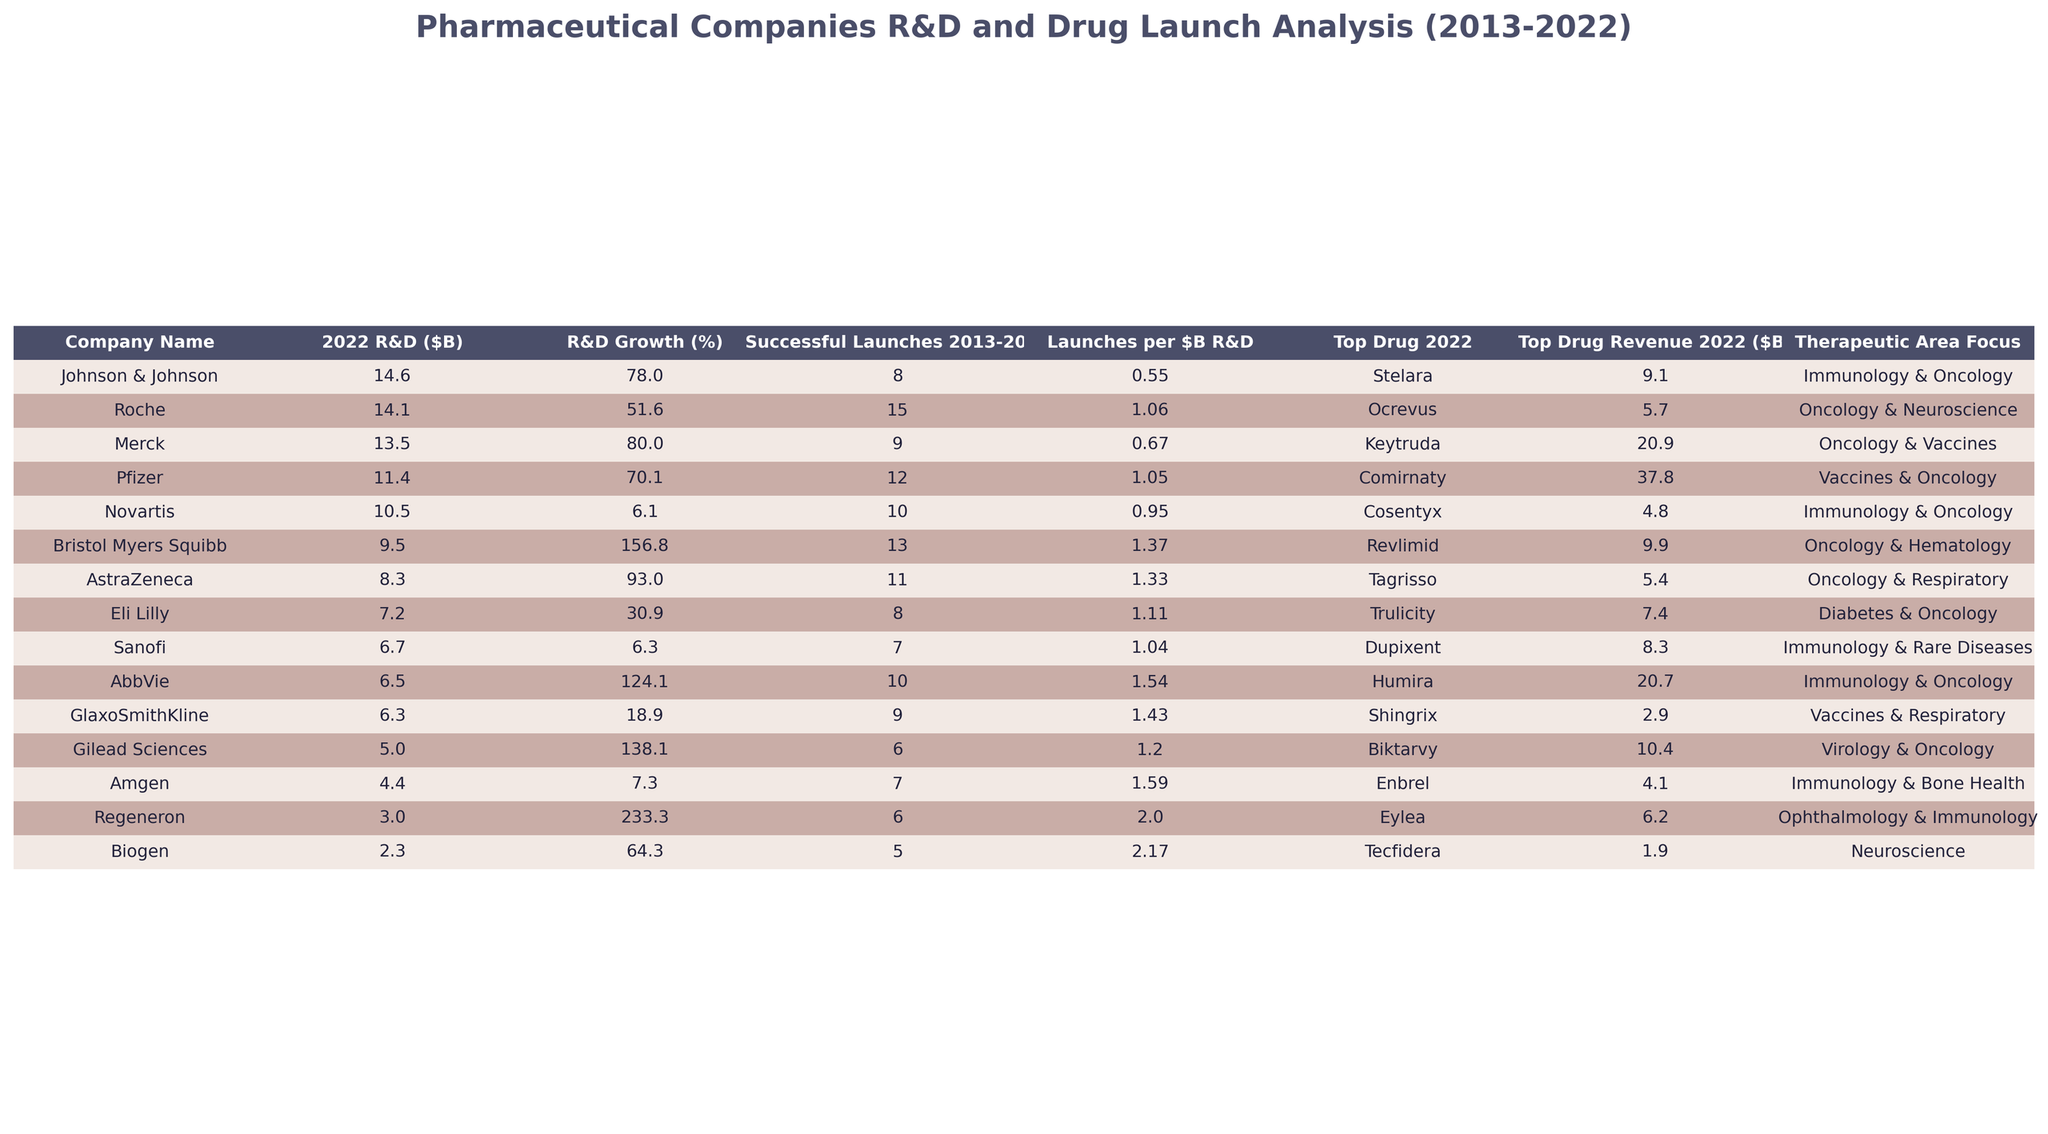What is the R&D expenditure of Pfizer in 2022? Referring to the table, Pfizer's R&D expenditure in 2022 is recorded as 11.4 billion dollars.
Answer: 11.4 billion dollars Which company had the highest number of successful launches between 2013 and 2022? From the table, Pfizer shows the highest number of successful launches, totaling 12.
Answer: Pfizer What is the R&D growth percentage of Merck from 2013 to 2022? Merck's R&D in 2013 was 7.5 billion dollars, and in 2022 it is 13.5 billion dollars. The growth percentage is calculated as ((13.5-7.5)/7.5) * 100 = 80%.
Answer: 80% Which company has the highest revenue from its top drug in 2022, and what is the drug? The table indicates that Comirnaty from Pfizer generates 37.8 billion dollars, which is higher than any other top drug revenue listed.
Answer: Pfizer; Comirnaty What is the total R&D expenditure of Johnson & Johnson and Merck in 2022? Johnson & Johnson's 2022 R&D is 14.6 billion dollars and Merck's is 13.5 billion dollars. Adding these gives 14.6 + 13.5 = 28.1 billion dollars.
Answer: 28.1 billion dollars Is Gilead Sciences' R&D expenditure in 2022 greater than that of Biogen? Gilead Sciences has an R&D expenditure of 5.0 billion dollars, whereas Biogen has 2.3 billion dollars. Therefore, Gilead Sciences' expenditure is greater.
Answer: Yes What is the average R&D expenditure of the companies listed in the table for 2022? Adding the 2022 R&D expenditures of all companies gives a total of 11.4 + 14.1 + 10.5 + 14.6 + 13.5 + 8.3 + 6.7 + 6.3 + 9.5 + 7.2 + 5.0 + 4.4 + 6.5 + 2.3 + 3.0 = 109.8 billion dollars. There are 15 companies, so the average is 109.8 / 15 = 7.32 billion dollars.
Answer: 7.32 billion dollars Which therapeutic area is the focus of the top drug for Regeneron? According to the table, the top drug for Regeneron is Eylea, and its therapeutic area focus is Ophthalmology & Immunology.
Answer: Ophthalmology & Immunology How many launches per billion dollars of R&D did AstraZeneca achieve? AstraZeneca successfully launched 11 drugs with an R&D expenditure of 8.3 billion dollars in 2022. Calculating gives 11 / 8.3 ≈ 1.32 launches per billion dollars.
Answer: 1.32 launches per billion dollars Did any company spend less on R&D in 2022 than they did in 2018? Referring to the data, Sanofi had an expenditure of 6.2 billion dollars in 2018 and 6.7 billion dollars in 2022, indicating an increase, while the other companies also show an increase or consistent values. Hence, no company spent less in 2022.
Answer: No 